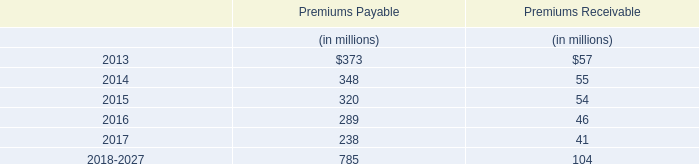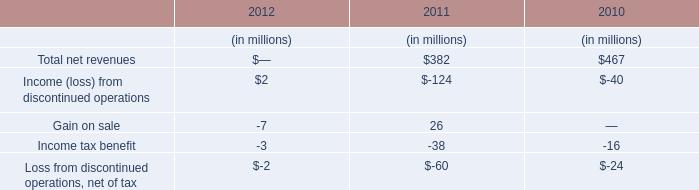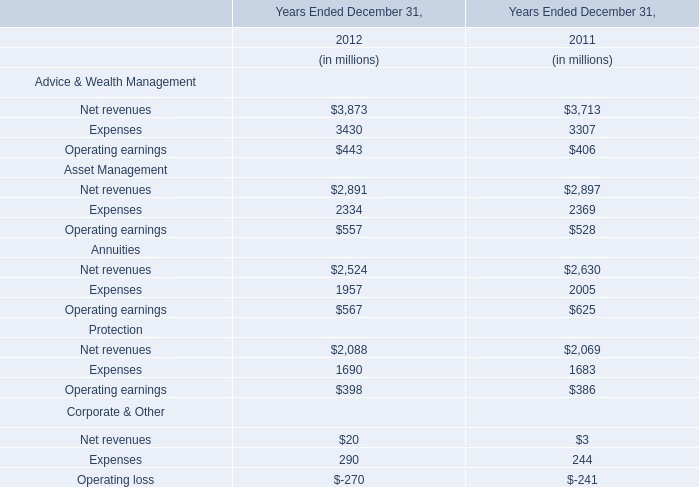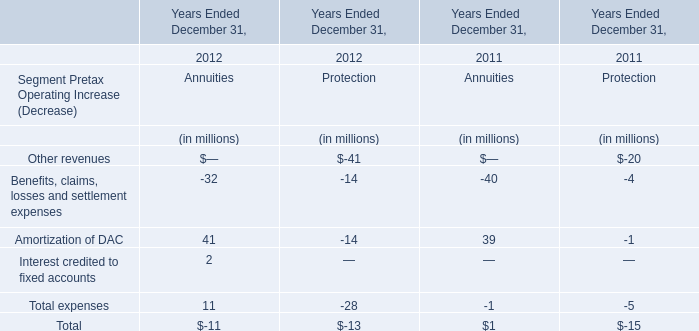What's the average of Total expenses of Annuities in 2012 and 2011? (in million) 
Computations: ((11 - 1) / 2)
Answer: 5.0. 